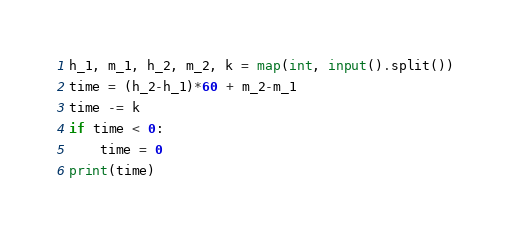Convert code to text. <code><loc_0><loc_0><loc_500><loc_500><_Python_>h_1, m_1, h_2, m_2, k = map(int, input().split())
time = (h_2-h_1)*60 + m_2-m_1
time -= k
if time < 0:
    time = 0
print(time)</code> 